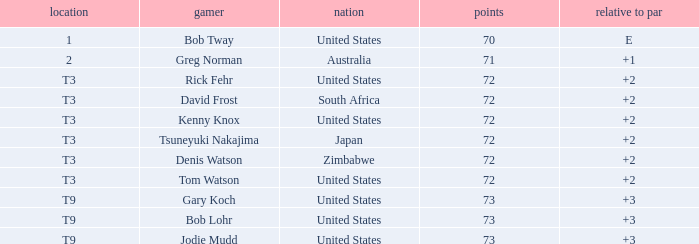Who scored more than 72? Gary Koch, Bob Lohr, Jodie Mudd. Help me parse the entirety of this table. {'header': ['location', 'gamer', 'nation', 'points', 'relative to par'], 'rows': [['1', 'Bob Tway', 'United States', '70', 'E'], ['2', 'Greg Norman', 'Australia', '71', '+1'], ['T3', 'Rick Fehr', 'United States', '72', '+2'], ['T3', 'David Frost', 'South Africa', '72', '+2'], ['T3', 'Kenny Knox', 'United States', '72', '+2'], ['T3', 'Tsuneyuki Nakajima', 'Japan', '72', '+2'], ['T3', 'Denis Watson', 'Zimbabwe', '72', '+2'], ['T3', 'Tom Watson', 'United States', '72', '+2'], ['T9', 'Gary Koch', 'United States', '73', '+3'], ['T9', 'Bob Lohr', 'United States', '73', '+3'], ['T9', 'Jodie Mudd', 'United States', '73', '+3']]} 